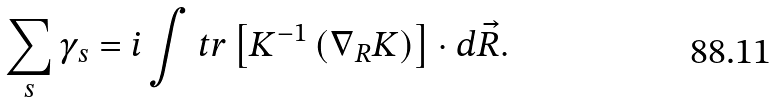Convert formula to latex. <formula><loc_0><loc_0><loc_500><loc_500>\sum _ { s } \gamma _ { s } = i \int t r \left [ { K } ^ { - 1 } \left ( \nabla _ { R } { K } \right ) \right ] \cdot d \vec { R } .</formula> 